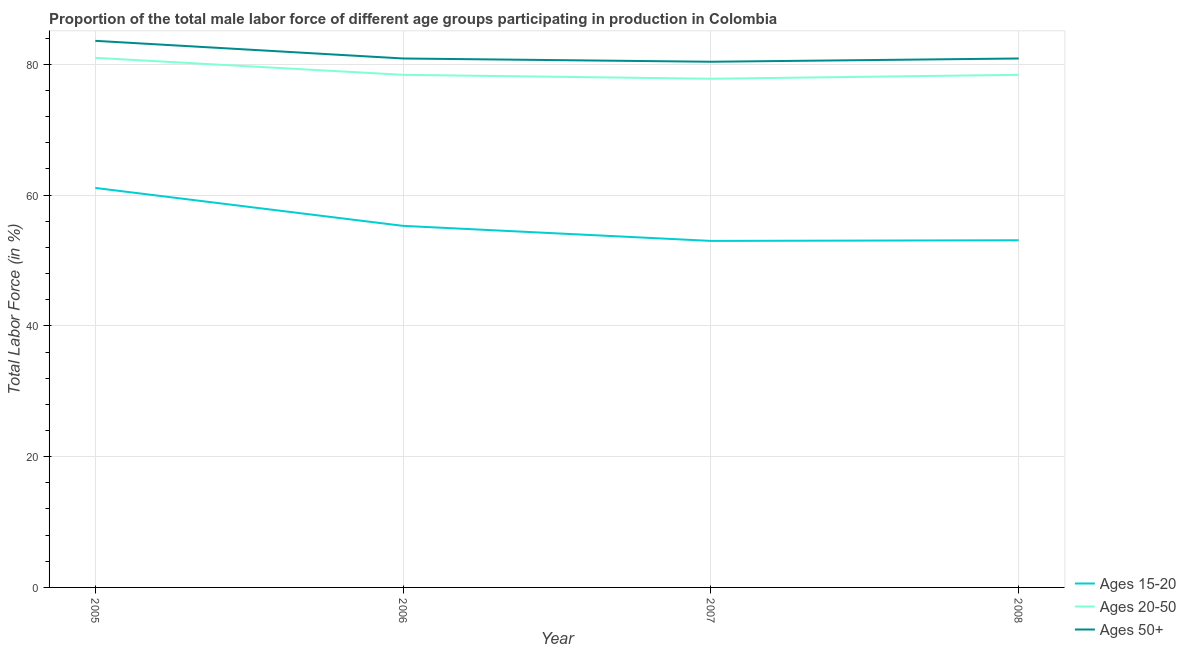How many different coloured lines are there?
Your answer should be very brief. 3. Is the number of lines equal to the number of legend labels?
Offer a terse response. Yes. What is the percentage of male labor force above age 50 in 2006?
Make the answer very short. 80.9. Across all years, what is the minimum percentage of male labor force within the age group 15-20?
Keep it short and to the point. 53. What is the total percentage of male labor force within the age group 15-20 in the graph?
Keep it short and to the point. 222.5. What is the difference between the percentage of male labor force within the age group 15-20 in 2006 and that in 2007?
Give a very brief answer. 2.3. What is the difference between the percentage of male labor force within the age group 20-50 in 2007 and the percentage of male labor force above age 50 in 2005?
Provide a short and direct response. -5.8. What is the average percentage of male labor force within the age group 20-50 per year?
Offer a very short reply. 78.9. In the year 2008, what is the difference between the percentage of male labor force within the age group 20-50 and percentage of male labor force above age 50?
Offer a terse response. -2.5. What is the ratio of the percentage of male labor force within the age group 20-50 in 2006 to that in 2008?
Offer a very short reply. 1. Is the percentage of male labor force within the age group 15-20 in 2005 less than that in 2006?
Your answer should be compact. No. Is the difference between the percentage of male labor force within the age group 15-20 in 2005 and 2006 greater than the difference between the percentage of male labor force above age 50 in 2005 and 2006?
Your answer should be compact. Yes. What is the difference between the highest and the second highest percentage of male labor force above age 50?
Make the answer very short. 2.7. What is the difference between the highest and the lowest percentage of male labor force within the age group 20-50?
Provide a succinct answer. 3.2. In how many years, is the percentage of male labor force above age 50 greater than the average percentage of male labor force above age 50 taken over all years?
Offer a very short reply. 1. Is it the case that in every year, the sum of the percentage of male labor force within the age group 15-20 and percentage of male labor force within the age group 20-50 is greater than the percentage of male labor force above age 50?
Your response must be concise. Yes. Is the percentage of male labor force above age 50 strictly greater than the percentage of male labor force within the age group 15-20 over the years?
Give a very brief answer. Yes. What is the difference between two consecutive major ticks on the Y-axis?
Offer a very short reply. 20. Does the graph contain any zero values?
Give a very brief answer. No. Does the graph contain grids?
Provide a short and direct response. Yes. Where does the legend appear in the graph?
Provide a short and direct response. Bottom right. What is the title of the graph?
Your answer should be compact. Proportion of the total male labor force of different age groups participating in production in Colombia. What is the Total Labor Force (in %) of Ages 15-20 in 2005?
Ensure brevity in your answer.  61.1. What is the Total Labor Force (in %) in Ages 20-50 in 2005?
Offer a terse response. 81. What is the Total Labor Force (in %) of Ages 50+ in 2005?
Offer a very short reply. 83.6. What is the Total Labor Force (in %) of Ages 15-20 in 2006?
Your answer should be compact. 55.3. What is the Total Labor Force (in %) of Ages 20-50 in 2006?
Keep it short and to the point. 78.4. What is the Total Labor Force (in %) in Ages 50+ in 2006?
Your answer should be very brief. 80.9. What is the Total Labor Force (in %) in Ages 20-50 in 2007?
Provide a succinct answer. 77.8. What is the Total Labor Force (in %) of Ages 50+ in 2007?
Give a very brief answer. 80.4. What is the Total Labor Force (in %) of Ages 15-20 in 2008?
Your answer should be very brief. 53.1. What is the Total Labor Force (in %) in Ages 20-50 in 2008?
Provide a succinct answer. 78.4. What is the Total Labor Force (in %) of Ages 50+ in 2008?
Your answer should be very brief. 80.9. Across all years, what is the maximum Total Labor Force (in %) of Ages 15-20?
Provide a short and direct response. 61.1. Across all years, what is the maximum Total Labor Force (in %) of Ages 20-50?
Ensure brevity in your answer.  81. Across all years, what is the maximum Total Labor Force (in %) in Ages 50+?
Offer a very short reply. 83.6. Across all years, what is the minimum Total Labor Force (in %) in Ages 15-20?
Make the answer very short. 53. Across all years, what is the minimum Total Labor Force (in %) in Ages 20-50?
Provide a succinct answer. 77.8. Across all years, what is the minimum Total Labor Force (in %) in Ages 50+?
Make the answer very short. 80.4. What is the total Total Labor Force (in %) in Ages 15-20 in the graph?
Your answer should be very brief. 222.5. What is the total Total Labor Force (in %) in Ages 20-50 in the graph?
Provide a short and direct response. 315.6. What is the total Total Labor Force (in %) in Ages 50+ in the graph?
Ensure brevity in your answer.  325.8. What is the difference between the Total Labor Force (in %) of Ages 15-20 in 2005 and that in 2006?
Offer a terse response. 5.8. What is the difference between the Total Labor Force (in %) in Ages 50+ in 2005 and that in 2006?
Give a very brief answer. 2.7. What is the difference between the Total Labor Force (in %) of Ages 15-20 in 2005 and that in 2007?
Your response must be concise. 8.1. What is the difference between the Total Labor Force (in %) in Ages 50+ in 2005 and that in 2007?
Keep it short and to the point. 3.2. What is the difference between the Total Labor Force (in %) in Ages 50+ in 2005 and that in 2008?
Your response must be concise. 2.7. What is the difference between the Total Labor Force (in %) of Ages 15-20 in 2006 and that in 2007?
Your answer should be very brief. 2.3. What is the difference between the Total Labor Force (in %) of Ages 50+ in 2006 and that in 2007?
Give a very brief answer. 0.5. What is the difference between the Total Labor Force (in %) in Ages 15-20 in 2006 and that in 2008?
Provide a succinct answer. 2.2. What is the difference between the Total Labor Force (in %) in Ages 15-20 in 2007 and that in 2008?
Give a very brief answer. -0.1. What is the difference between the Total Labor Force (in %) in Ages 20-50 in 2007 and that in 2008?
Your response must be concise. -0.6. What is the difference between the Total Labor Force (in %) in Ages 50+ in 2007 and that in 2008?
Provide a short and direct response. -0.5. What is the difference between the Total Labor Force (in %) of Ages 15-20 in 2005 and the Total Labor Force (in %) of Ages 20-50 in 2006?
Make the answer very short. -17.3. What is the difference between the Total Labor Force (in %) of Ages 15-20 in 2005 and the Total Labor Force (in %) of Ages 50+ in 2006?
Provide a short and direct response. -19.8. What is the difference between the Total Labor Force (in %) of Ages 20-50 in 2005 and the Total Labor Force (in %) of Ages 50+ in 2006?
Offer a very short reply. 0.1. What is the difference between the Total Labor Force (in %) of Ages 15-20 in 2005 and the Total Labor Force (in %) of Ages 20-50 in 2007?
Make the answer very short. -16.7. What is the difference between the Total Labor Force (in %) in Ages 15-20 in 2005 and the Total Labor Force (in %) in Ages 50+ in 2007?
Give a very brief answer. -19.3. What is the difference between the Total Labor Force (in %) of Ages 15-20 in 2005 and the Total Labor Force (in %) of Ages 20-50 in 2008?
Offer a very short reply. -17.3. What is the difference between the Total Labor Force (in %) of Ages 15-20 in 2005 and the Total Labor Force (in %) of Ages 50+ in 2008?
Your answer should be very brief. -19.8. What is the difference between the Total Labor Force (in %) of Ages 15-20 in 2006 and the Total Labor Force (in %) of Ages 20-50 in 2007?
Provide a succinct answer. -22.5. What is the difference between the Total Labor Force (in %) of Ages 15-20 in 2006 and the Total Labor Force (in %) of Ages 50+ in 2007?
Provide a succinct answer. -25.1. What is the difference between the Total Labor Force (in %) in Ages 20-50 in 2006 and the Total Labor Force (in %) in Ages 50+ in 2007?
Provide a succinct answer. -2. What is the difference between the Total Labor Force (in %) in Ages 15-20 in 2006 and the Total Labor Force (in %) in Ages 20-50 in 2008?
Your response must be concise. -23.1. What is the difference between the Total Labor Force (in %) in Ages 15-20 in 2006 and the Total Labor Force (in %) in Ages 50+ in 2008?
Make the answer very short. -25.6. What is the difference between the Total Labor Force (in %) in Ages 15-20 in 2007 and the Total Labor Force (in %) in Ages 20-50 in 2008?
Your answer should be compact. -25.4. What is the difference between the Total Labor Force (in %) in Ages 15-20 in 2007 and the Total Labor Force (in %) in Ages 50+ in 2008?
Give a very brief answer. -27.9. What is the difference between the Total Labor Force (in %) in Ages 20-50 in 2007 and the Total Labor Force (in %) in Ages 50+ in 2008?
Offer a terse response. -3.1. What is the average Total Labor Force (in %) in Ages 15-20 per year?
Your answer should be compact. 55.62. What is the average Total Labor Force (in %) in Ages 20-50 per year?
Offer a terse response. 78.9. What is the average Total Labor Force (in %) of Ages 50+ per year?
Offer a terse response. 81.45. In the year 2005, what is the difference between the Total Labor Force (in %) of Ages 15-20 and Total Labor Force (in %) of Ages 20-50?
Ensure brevity in your answer.  -19.9. In the year 2005, what is the difference between the Total Labor Force (in %) of Ages 15-20 and Total Labor Force (in %) of Ages 50+?
Your response must be concise. -22.5. In the year 2006, what is the difference between the Total Labor Force (in %) in Ages 15-20 and Total Labor Force (in %) in Ages 20-50?
Your answer should be compact. -23.1. In the year 2006, what is the difference between the Total Labor Force (in %) of Ages 15-20 and Total Labor Force (in %) of Ages 50+?
Your response must be concise. -25.6. In the year 2007, what is the difference between the Total Labor Force (in %) in Ages 15-20 and Total Labor Force (in %) in Ages 20-50?
Provide a succinct answer. -24.8. In the year 2007, what is the difference between the Total Labor Force (in %) in Ages 15-20 and Total Labor Force (in %) in Ages 50+?
Provide a succinct answer. -27.4. In the year 2007, what is the difference between the Total Labor Force (in %) of Ages 20-50 and Total Labor Force (in %) of Ages 50+?
Offer a very short reply. -2.6. In the year 2008, what is the difference between the Total Labor Force (in %) in Ages 15-20 and Total Labor Force (in %) in Ages 20-50?
Keep it short and to the point. -25.3. In the year 2008, what is the difference between the Total Labor Force (in %) in Ages 15-20 and Total Labor Force (in %) in Ages 50+?
Make the answer very short. -27.8. In the year 2008, what is the difference between the Total Labor Force (in %) of Ages 20-50 and Total Labor Force (in %) of Ages 50+?
Ensure brevity in your answer.  -2.5. What is the ratio of the Total Labor Force (in %) of Ages 15-20 in 2005 to that in 2006?
Your answer should be very brief. 1.1. What is the ratio of the Total Labor Force (in %) of Ages 20-50 in 2005 to that in 2006?
Make the answer very short. 1.03. What is the ratio of the Total Labor Force (in %) of Ages 50+ in 2005 to that in 2006?
Your response must be concise. 1.03. What is the ratio of the Total Labor Force (in %) in Ages 15-20 in 2005 to that in 2007?
Keep it short and to the point. 1.15. What is the ratio of the Total Labor Force (in %) of Ages 20-50 in 2005 to that in 2007?
Your response must be concise. 1.04. What is the ratio of the Total Labor Force (in %) in Ages 50+ in 2005 to that in 2007?
Offer a terse response. 1.04. What is the ratio of the Total Labor Force (in %) in Ages 15-20 in 2005 to that in 2008?
Give a very brief answer. 1.15. What is the ratio of the Total Labor Force (in %) in Ages 20-50 in 2005 to that in 2008?
Your answer should be compact. 1.03. What is the ratio of the Total Labor Force (in %) of Ages 50+ in 2005 to that in 2008?
Offer a very short reply. 1.03. What is the ratio of the Total Labor Force (in %) in Ages 15-20 in 2006 to that in 2007?
Keep it short and to the point. 1.04. What is the ratio of the Total Labor Force (in %) in Ages 20-50 in 2006 to that in 2007?
Provide a short and direct response. 1.01. What is the ratio of the Total Labor Force (in %) of Ages 15-20 in 2006 to that in 2008?
Provide a short and direct response. 1.04. What is the ratio of the Total Labor Force (in %) in Ages 20-50 in 2006 to that in 2008?
Your answer should be compact. 1. What is the ratio of the Total Labor Force (in %) in Ages 15-20 in 2007 to that in 2008?
Keep it short and to the point. 1. What is the ratio of the Total Labor Force (in %) of Ages 50+ in 2007 to that in 2008?
Make the answer very short. 0.99. What is the difference between the highest and the second highest Total Labor Force (in %) in Ages 15-20?
Your answer should be very brief. 5.8. What is the difference between the highest and the second highest Total Labor Force (in %) in Ages 50+?
Offer a terse response. 2.7. What is the difference between the highest and the lowest Total Labor Force (in %) of Ages 20-50?
Provide a short and direct response. 3.2. 